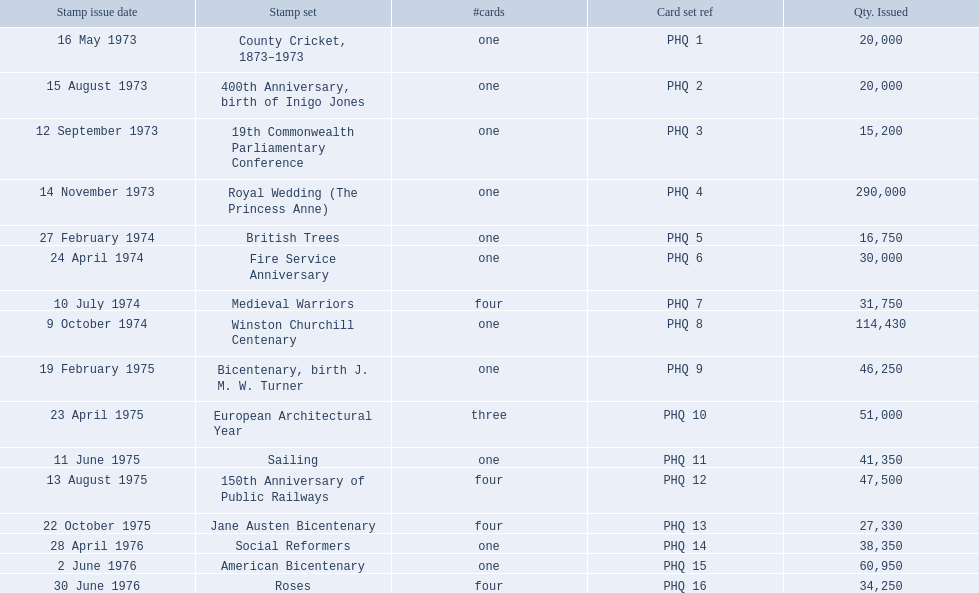Which stamp collections included multiple cards? Medieval Warriors, European Architectural Year, 150th Anniversary of Public Railways, Jane Austen Bicentenary, Roses. Would you mind parsing the complete table? {'header': ['Stamp issue date', 'Stamp set', '#cards', 'Card set ref', 'Qty. Issued'], 'rows': [['16 May 1973', 'County Cricket, 1873–1973', 'one', 'PHQ 1', '20,000'], ['15 August 1973', '400th Anniversary, birth of Inigo Jones', 'one', 'PHQ 2', '20,000'], ['12 September 1973', '19th Commonwealth Parliamentary Conference', 'one', 'PHQ 3', '15,200'], ['14 November 1973', 'Royal Wedding (The Princess Anne)', 'one', 'PHQ 4', '290,000'], ['27 February 1974', 'British Trees', 'one', 'PHQ 5', '16,750'], ['24 April 1974', 'Fire Service Anniversary', 'one', 'PHQ 6', '30,000'], ['10 July 1974', 'Medieval Warriors', 'four', 'PHQ 7', '31,750'], ['9 October 1974', 'Winston Churchill Centenary', 'one', 'PHQ 8', '114,430'], ['19 February 1975', 'Bicentenary, birth J. M. W. Turner', 'one', 'PHQ 9', '46,250'], ['23 April 1975', 'European Architectural Year', 'three', 'PHQ 10', '51,000'], ['11 June 1975', 'Sailing', 'one', 'PHQ 11', '41,350'], ['13 August 1975', '150th Anniversary of Public Railways', 'four', 'PHQ 12', '47,500'], ['22 October 1975', 'Jane Austen Bicentenary', 'four', 'PHQ 13', '27,330'], ['28 April 1976', 'Social Reformers', 'one', 'PHQ 14', '38,350'], ['2 June 1976', 'American Bicentenary', 'one', 'PHQ 15', '60,950'], ['30 June 1976', 'Roses', 'four', 'PHQ 16', '34,250']]} Of those collections, which has a distinct quantity of cards? European Architectural Year. 